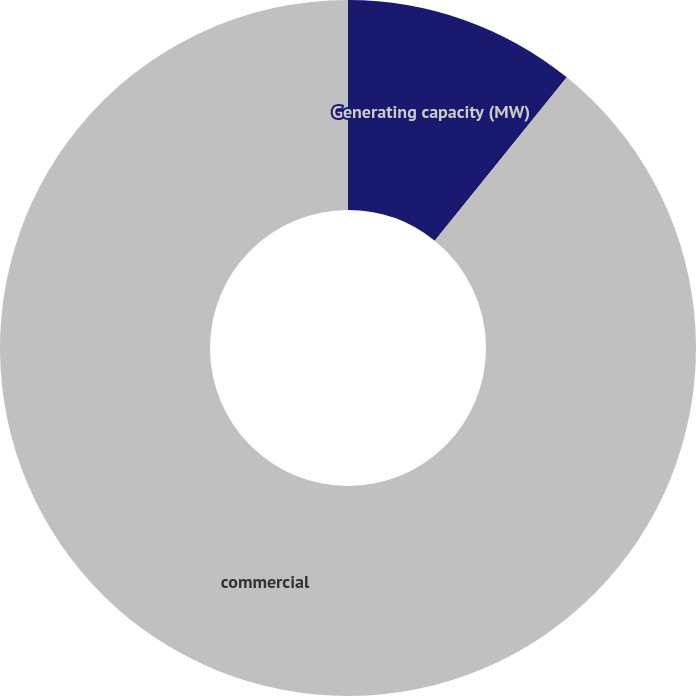<chart> <loc_0><loc_0><loc_500><loc_500><pie_chart><fcel>Generating capacity (MW)<fcel>commercial<nl><fcel>10.82%<fcel>89.18%<nl></chart> 